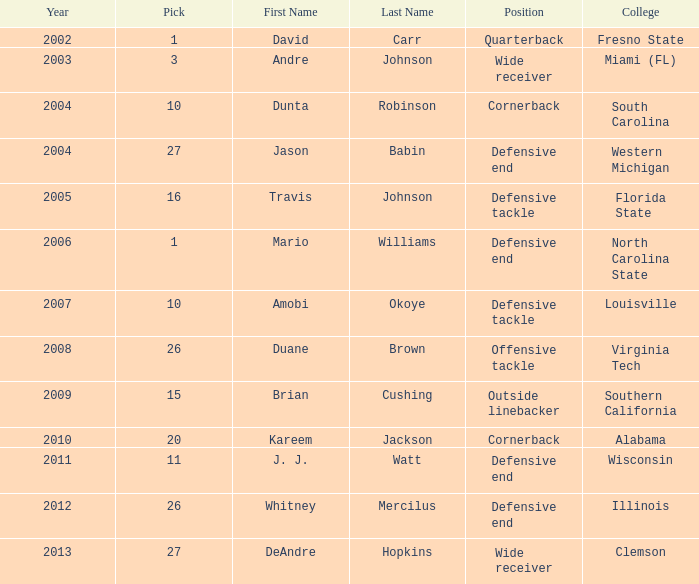What pick was mario williams before 2006? None. 